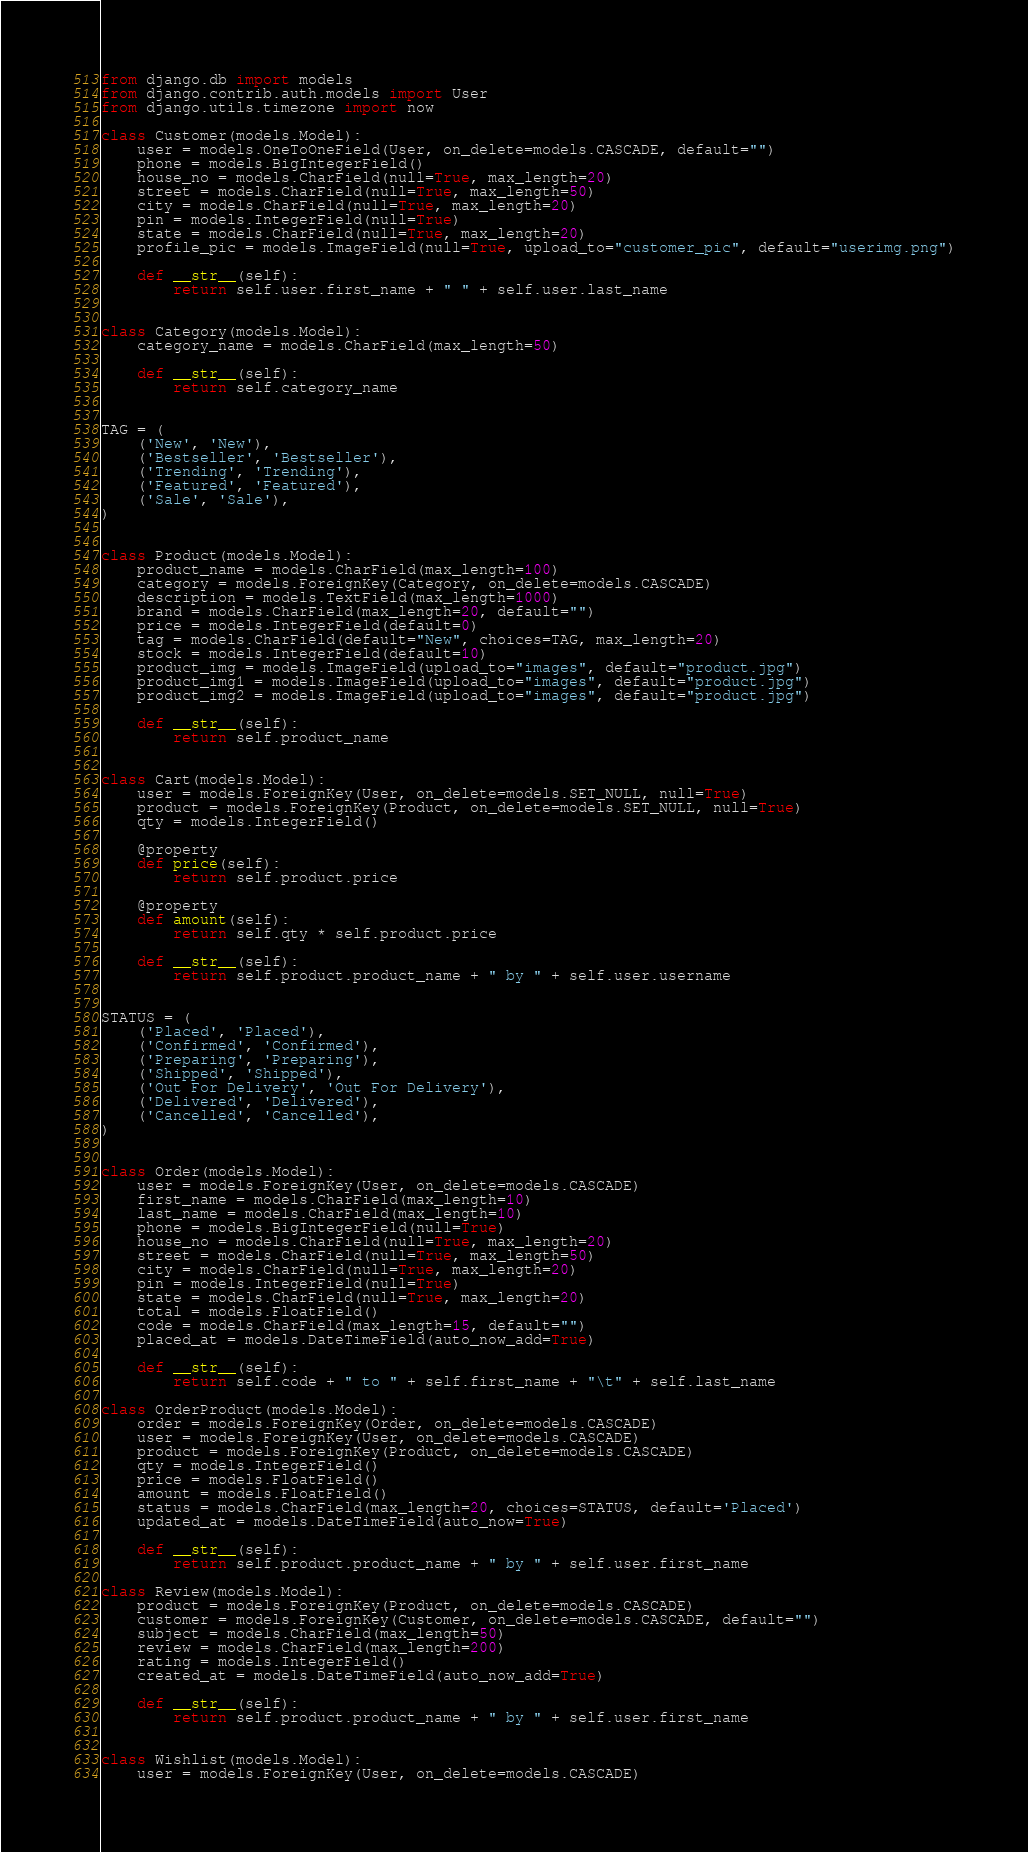Convert code to text. <code><loc_0><loc_0><loc_500><loc_500><_Python_>from django.db import models
from django.contrib.auth.models import User
from django.utils.timezone import now

class Customer(models.Model):
    user = models.OneToOneField(User, on_delete=models.CASCADE, default="")
    phone = models.BigIntegerField()
    house_no = models.CharField(null=True, max_length=20)
    street = models.CharField(null=True, max_length=50)
    city = models.CharField(null=True, max_length=20)
    pin = models.IntegerField(null=True)
    state = models.CharField(null=True, max_length=20)
    profile_pic = models.ImageField(null=True, upload_to="customer_pic", default="userimg.png")

    def __str__(self):
        return self.user.first_name + " " + self.user.last_name


class Category(models.Model):
    category_name = models.CharField(max_length=50)

    def __str__(self):
        return self.category_name


TAG = (
    ('New', 'New'),
    ('Bestseller', 'Bestseller'),
    ('Trending', 'Trending'),
    ('Featured', 'Featured'),
    ('Sale', 'Sale'),
)


class Product(models.Model):
    product_name = models.CharField(max_length=100)
    category = models.ForeignKey(Category, on_delete=models.CASCADE)
    description = models.TextField(max_length=1000)
    brand = models.CharField(max_length=20, default="")
    price = models.IntegerField(default=0)
    tag = models.CharField(default="New", choices=TAG, max_length=20)
    stock = models.IntegerField(default=10)
    product_img = models.ImageField(upload_to="images", default="product.jpg")
    product_img1 = models.ImageField(upload_to="images", default="product.jpg")
    product_img2 = models.ImageField(upload_to="images", default="product.jpg")

    def __str__(self):
        return self.product_name


class Cart(models.Model):
    user = models.ForeignKey(User, on_delete=models.SET_NULL, null=True)
    product = models.ForeignKey(Product, on_delete=models.SET_NULL, null=True)
    qty = models.IntegerField()

    @property
    def price(self):
        return self.product.price

    @property
    def amount(self):
        return self.qty * self.product.price

    def __str__(self):
        return self.product.product_name + " by " + self.user.username


STATUS = (
    ('Placed', 'Placed'),
    ('Confirmed', 'Confirmed'),
    ('Preparing', 'Preparing'),
    ('Shipped', 'Shipped'),
    ('Out For Delivery', 'Out For Delivery'),
    ('Delivered', 'Delivered'),
    ('Cancelled', 'Cancelled'),
)


class Order(models.Model):
    user = models.ForeignKey(User, on_delete=models.CASCADE)
    first_name = models.CharField(max_length=10)
    last_name = models.CharField(max_length=10)
    phone = models.BigIntegerField(null=True)
    house_no = models.CharField(null=True, max_length=20)
    street = models.CharField(null=True, max_length=50)
    city = models.CharField(null=True, max_length=20)
    pin = models.IntegerField(null=True)
    state = models.CharField(null=True, max_length=20)
    total = models.FloatField()
    code = models.CharField(max_length=15, default="")
    placed_at = models.DateTimeField(auto_now_add=True)

    def __str__(self):
        return self.code + " to " + self.first_name + "\t" + self.last_name

class OrderProduct(models.Model):
    order = models.ForeignKey(Order, on_delete=models.CASCADE)
    user = models.ForeignKey(User, on_delete=models.CASCADE)
    product = models.ForeignKey(Product, on_delete=models.CASCADE)
    qty = models.IntegerField()
    price = models.FloatField()
    amount = models.FloatField()
    status = models.CharField(max_length=20, choices=STATUS, default='Placed')
    updated_at = models.DateTimeField(auto_now=True)

    def __str__(self):
        return self.product.product_name + " by " + self.user.first_name

class Review(models.Model):
    product = models.ForeignKey(Product, on_delete=models.CASCADE)
    customer = models.ForeignKey(Customer, on_delete=models.CASCADE, default="")
    subject = models.CharField(max_length=50)
    review = models.CharField(max_length=200)
    rating = models.IntegerField()
    created_at = models.DateTimeField(auto_now_add=True)

    def __str__(self):
        return self.product.product_name + " by " + self.user.first_name


class Wishlist(models.Model):
    user = models.ForeignKey(User, on_delete=models.CASCADE)</code> 